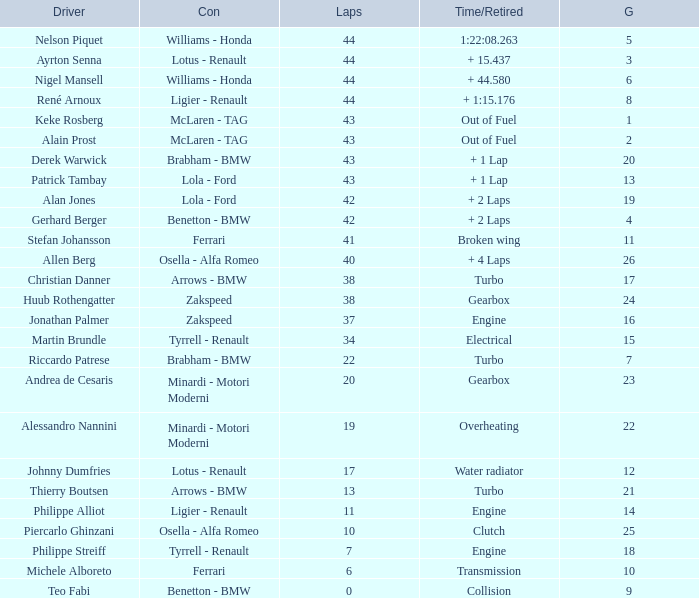Tell me the time/retired for Laps of 42 and Grids of 4 + 2 Laps. 